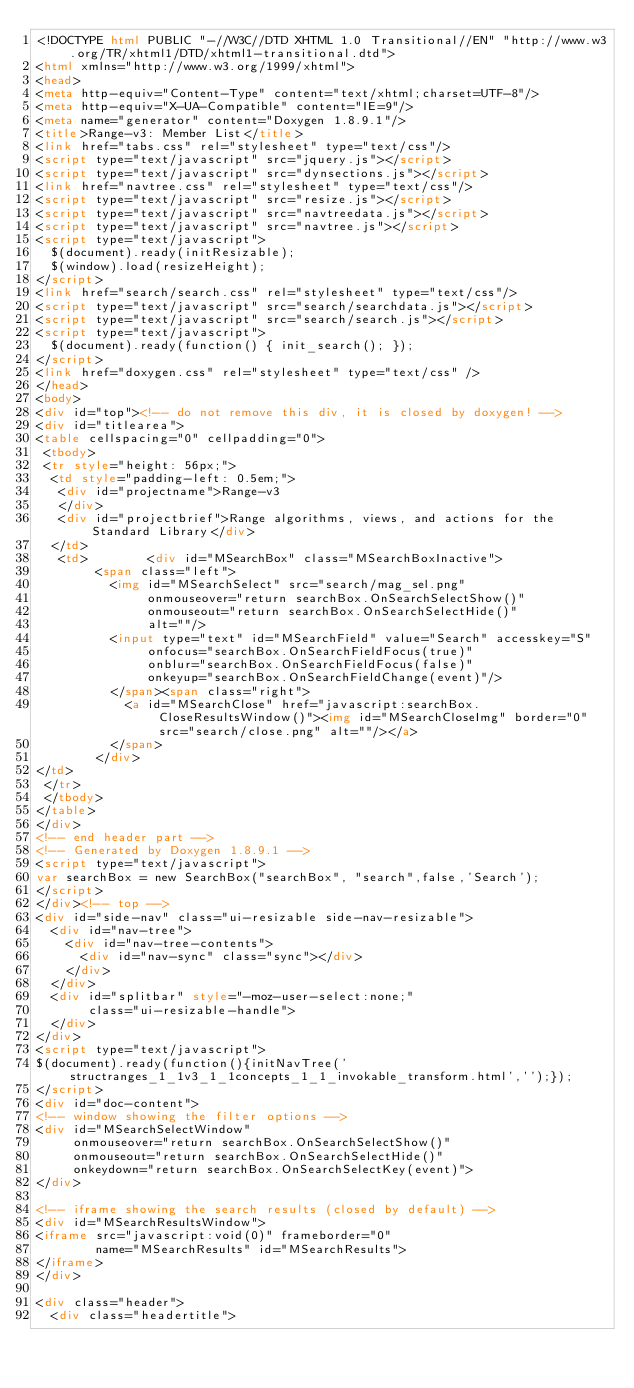<code> <loc_0><loc_0><loc_500><loc_500><_HTML_><!DOCTYPE html PUBLIC "-//W3C//DTD XHTML 1.0 Transitional//EN" "http://www.w3.org/TR/xhtml1/DTD/xhtml1-transitional.dtd">
<html xmlns="http://www.w3.org/1999/xhtml">
<head>
<meta http-equiv="Content-Type" content="text/xhtml;charset=UTF-8"/>
<meta http-equiv="X-UA-Compatible" content="IE=9"/>
<meta name="generator" content="Doxygen 1.8.9.1"/>
<title>Range-v3: Member List</title>
<link href="tabs.css" rel="stylesheet" type="text/css"/>
<script type="text/javascript" src="jquery.js"></script>
<script type="text/javascript" src="dynsections.js"></script>
<link href="navtree.css" rel="stylesheet" type="text/css"/>
<script type="text/javascript" src="resize.js"></script>
<script type="text/javascript" src="navtreedata.js"></script>
<script type="text/javascript" src="navtree.js"></script>
<script type="text/javascript">
  $(document).ready(initResizable);
  $(window).load(resizeHeight);
</script>
<link href="search/search.css" rel="stylesheet" type="text/css"/>
<script type="text/javascript" src="search/searchdata.js"></script>
<script type="text/javascript" src="search/search.js"></script>
<script type="text/javascript">
  $(document).ready(function() { init_search(); });
</script>
<link href="doxygen.css" rel="stylesheet" type="text/css" />
</head>
<body>
<div id="top"><!-- do not remove this div, it is closed by doxygen! -->
<div id="titlearea">
<table cellspacing="0" cellpadding="0">
 <tbody>
 <tr style="height: 56px;">
  <td style="padding-left: 0.5em;">
   <div id="projectname">Range-v3
   </div>
   <div id="projectbrief">Range algorithms, views, and actions for the Standard Library</div>
  </td>
   <td>        <div id="MSearchBox" class="MSearchBoxInactive">
        <span class="left">
          <img id="MSearchSelect" src="search/mag_sel.png"
               onmouseover="return searchBox.OnSearchSelectShow()"
               onmouseout="return searchBox.OnSearchSelectHide()"
               alt=""/>
          <input type="text" id="MSearchField" value="Search" accesskey="S"
               onfocus="searchBox.OnSearchFieldFocus(true)" 
               onblur="searchBox.OnSearchFieldFocus(false)" 
               onkeyup="searchBox.OnSearchFieldChange(event)"/>
          </span><span class="right">
            <a id="MSearchClose" href="javascript:searchBox.CloseResultsWindow()"><img id="MSearchCloseImg" border="0" src="search/close.png" alt=""/></a>
          </span>
        </div>
</td>
 </tr>
 </tbody>
</table>
</div>
<!-- end header part -->
<!-- Generated by Doxygen 1.8.9.1 -->
<script type="text/javascript">
var searchBox = new SearchBox("searchBox", "search",false,'Search');
</script>
</div><!-- top -->
<div id="side-nav" class="ui-resizable side-nav-resizable">
  <div id="nav-tree">
    <div id="nav-tree-contents">
      <div id="nav-sync" class="sync"></div>
    </div>
  </div>
  <div id="splitbar" style="-moz-user-select:none;" 
       class="ui-resizable-handle">
  </div>
</div>
<script type="text/javascript">
$(document).ready(function(){initNavTree('structranges_1_1v3_1_1concepts_1_1_invokable_transform.html','');});
</script>
<div id="doc-content">
<!-- window showing the filter options -->
<div id="MSearchSelectWindow"
     onmouseover="return searchBox.OnSearchSelectShow()"
     onmouseout="return searchBox.OnSearchSelectHide()"
     onkeydown="return searchBox.OnSearchSelectKey(event)">
</div>

<!-- iframe showing the search results (closed by default) -->
<div id="MSearchResultsWindow">
<iframe src="javascript:void(0)" frameborder="0" 
        name="MSearchResults" id="MSearchResults">
</iframe>
</div>

<div class="header">
  <div class="headertitle"></code> 